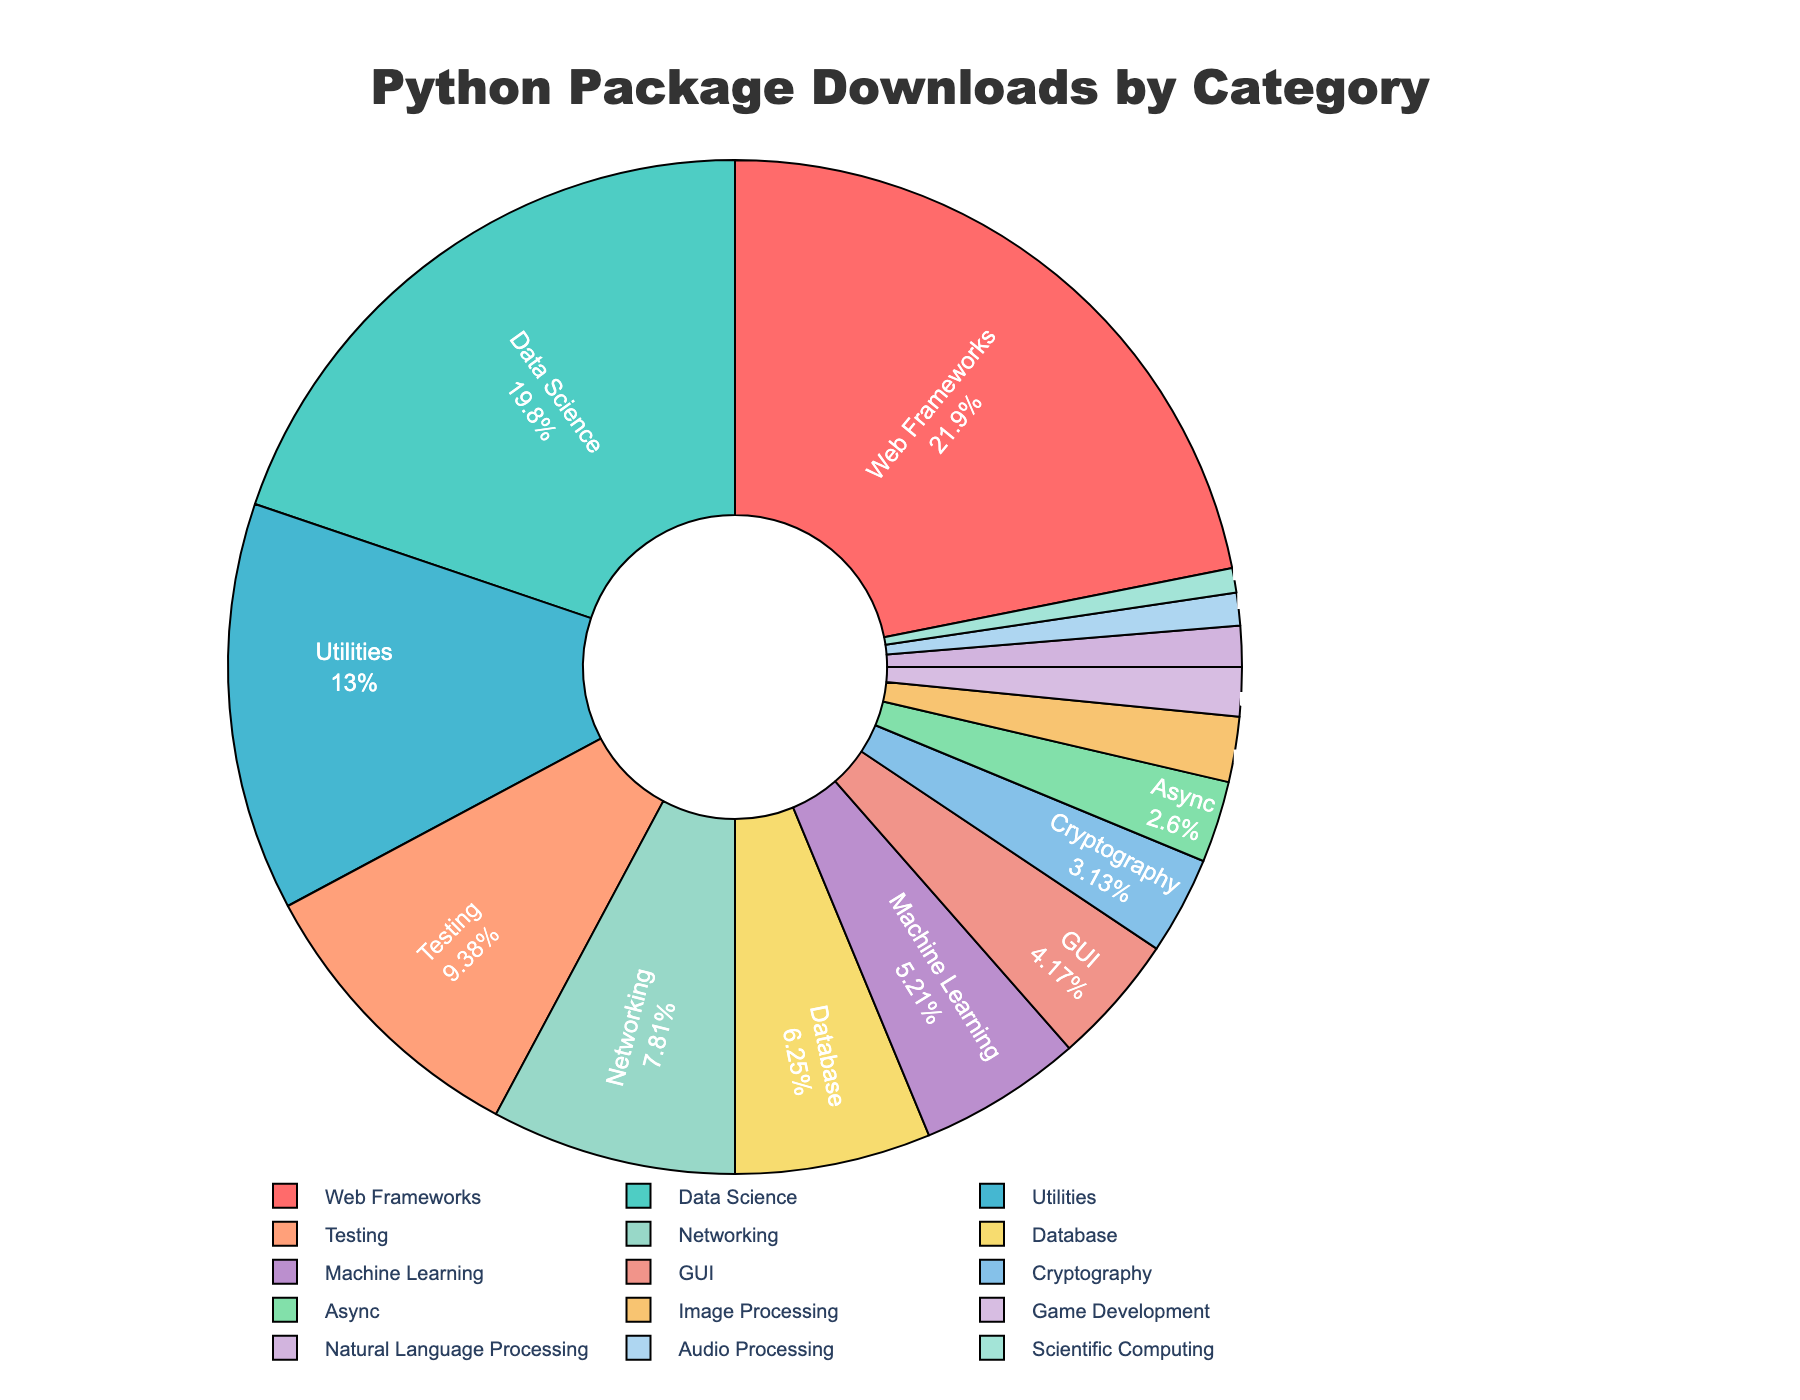Which category has the highest number of downloads? The pie chart shows that the Web Frameworks category has the largest slice, indicating it has the highest number of downloads.
Answer: Web Frameworks Which two categories have the lowest number of downloads combined? The two smallest slices in the pie chart belong to Audio Processing and Scientific Computing. Adding their downloads gives 2,000,000 (Audio Processing) + 1,500,000 (Scientific Computing) = 3,500,000.
Answer: Audio Processing and Scientific Computing How does the number of downloads for Data Science compare to Networking? By observing the sizes of the slices, Data Science has a larger slice than Networking. The numbers are 38,000,000 for Data Science and 15,000,000 for Networking, so Data Science has more downloads.
Answer: Data Science has more downloads than Networking What percentage of the total downloads are for the Machine Learning category? The pie chart shows the percentage of total downloads for each category in the slice labels. The Machine Learning category is labeled with its percentage, which is 10,000,000 out of the total downloads. The percentage is on the chart next to "Machine Learning".
Answer: Depends on the percentage shown Is the number of downloads for GUI more, less, or equal to Cryptography and Image Processing combined? From the pie chart, the number of downloads for GUI is 8,000,000, while Cryptography and Image Processing have 6,000,000 and 4,000,000 downloads respectively. Adding Cryptography and Image Processing gives 6,000,000 + 4,000,000 = 10,000,000, so GUI is less.
Answer: Less How many total downloads are accounted for by the top three most downloaded categories? The top three categories by the size of their slices are Web Frameworks, Data Science, and Utilities. Adding their downloads together gives 42,000,000 (Web Frameworks) + 38,000,000 (Data Science) + 25,000,000 (Utilities) = 105,000,000.
Answer: 105,000,000 What is the exact ratio of the downloads between Testing and Natural Language Processing categories? The Testing category has 18,000,000 downloads and the Natural Language Processing category has 2,500,000 downloads. The ratio can be calculated as 18,000,000 / 2,500,000 = 7.2.
Answer: 7.2 Which color is used to represent the Networking category in the chart, and what is the significance of the slice representing this category? The Networking category is represented by a particular color (visible in the pie chart). The significance is the relative size of the slice indicating it has fewer downloads than categories with larger slices.
Answer: Depends on the color shown What is the combined percentage of downloads for Data Science and Machine Learning categories? The pie chart provides the percentage for each category. Combine the percentages of Data Science and Machine Learning, e.g., if Data Science is X% and Machine Learning is Y%, then the combined percentage is X% + Y%.
Answer: X% + Y% Between Web Frameworks and Utilities, which category's downloads difference is closest to the downloads for Testing? Web Frameworks has 42,000,000 downloads and Utilities has 25,000,000. The difference is 42,000,000 - 25,000,000 = 17,000,000, which is almost the same as Testing's 18,000,000 downloads.
Answer: Web Frameworks and Utilities What visual attribute distinguishes Cryptography from Audio Processing at first glance? Cryptography's slice in the pie chart is slightly larger compared to Audio Processing's slice, and the color will be noticeably different.
Answer: Size and color differences 